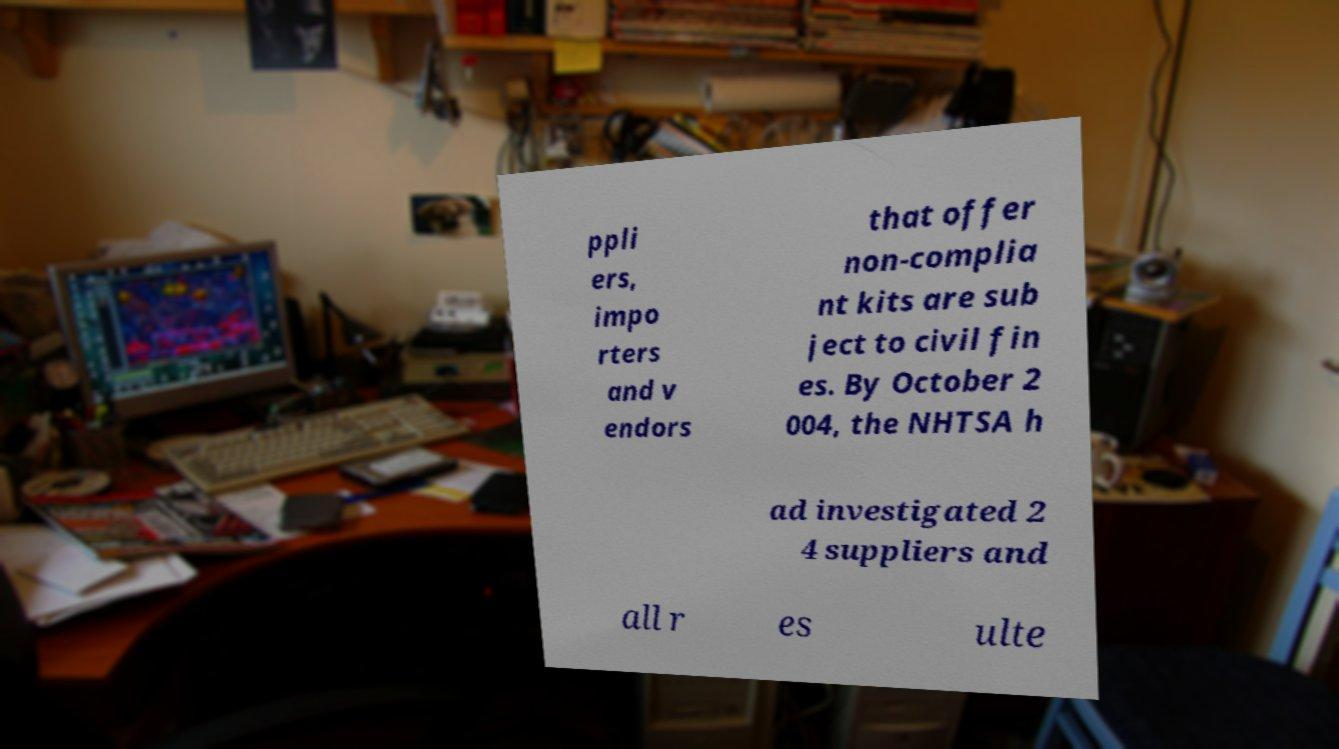Please identify and transcribe the text found in this image. ppli ers, impo rters and v endors that offer non-complia nt kits are sub ject to civil fin es. By October 2 004, the NHTSA h ad investigated 2 4 suppliers and all r es ulte 